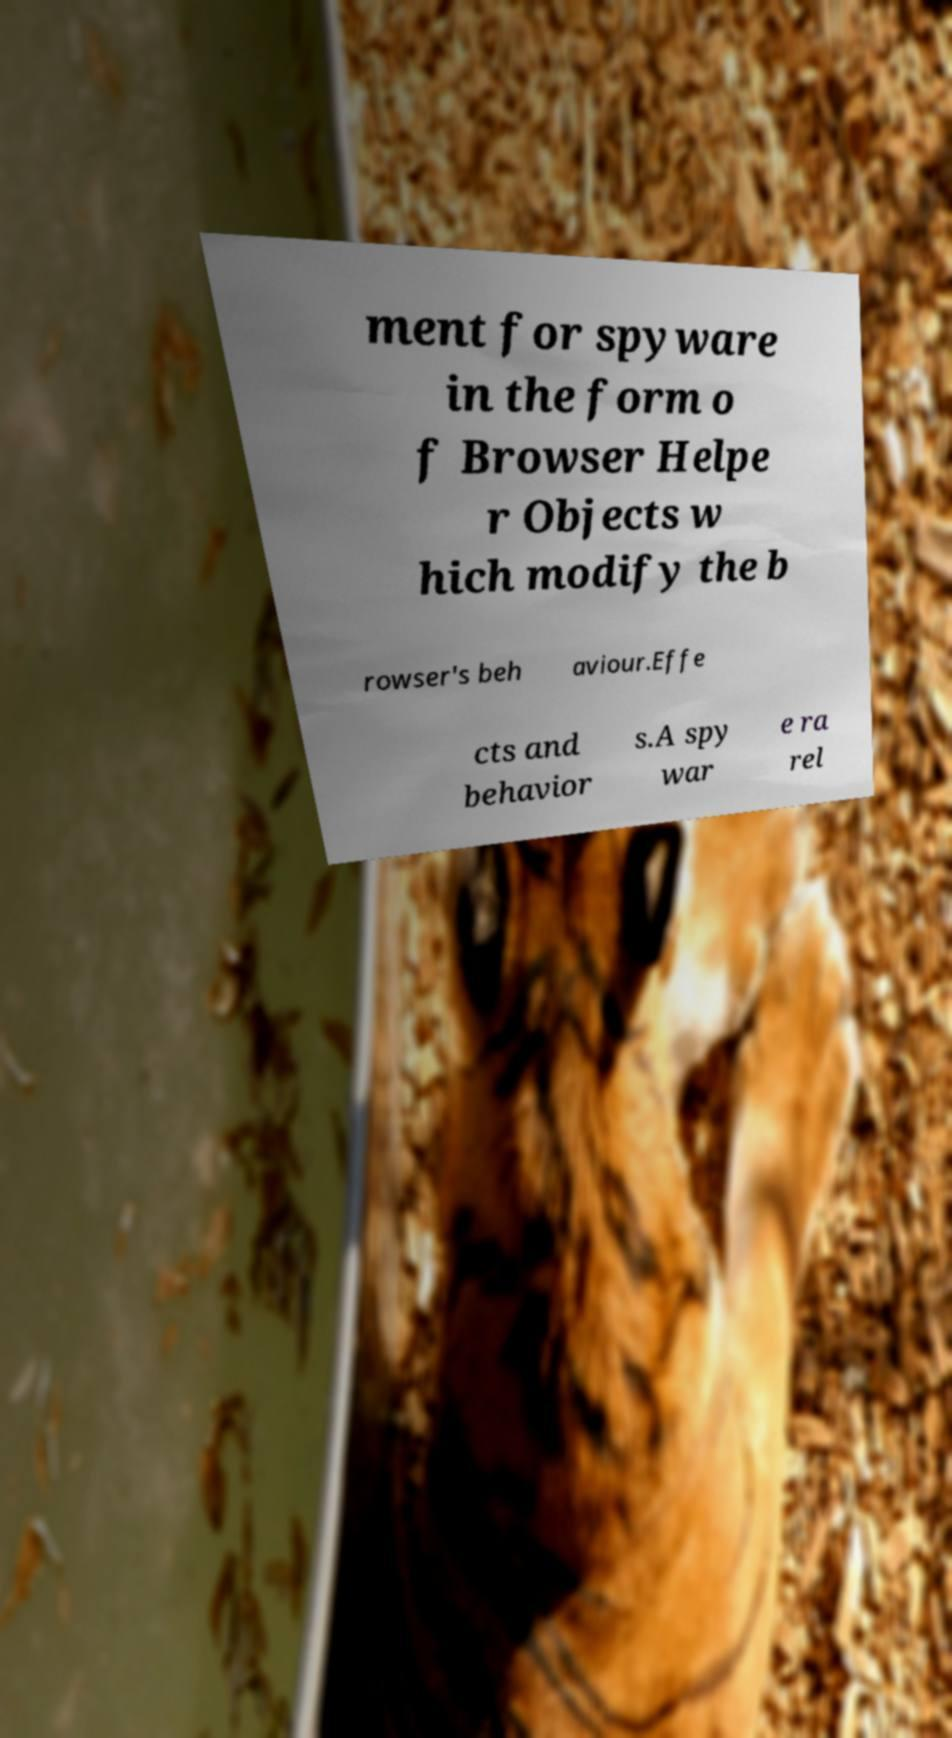What messages or text are displayed in this image? I need them in a readable, typed format. ment for spyware in the form o f Browser Helpe r Objects w hich modify the b rowser's beh aviour.Effe cts and behavior s.A spy war e ra rel 